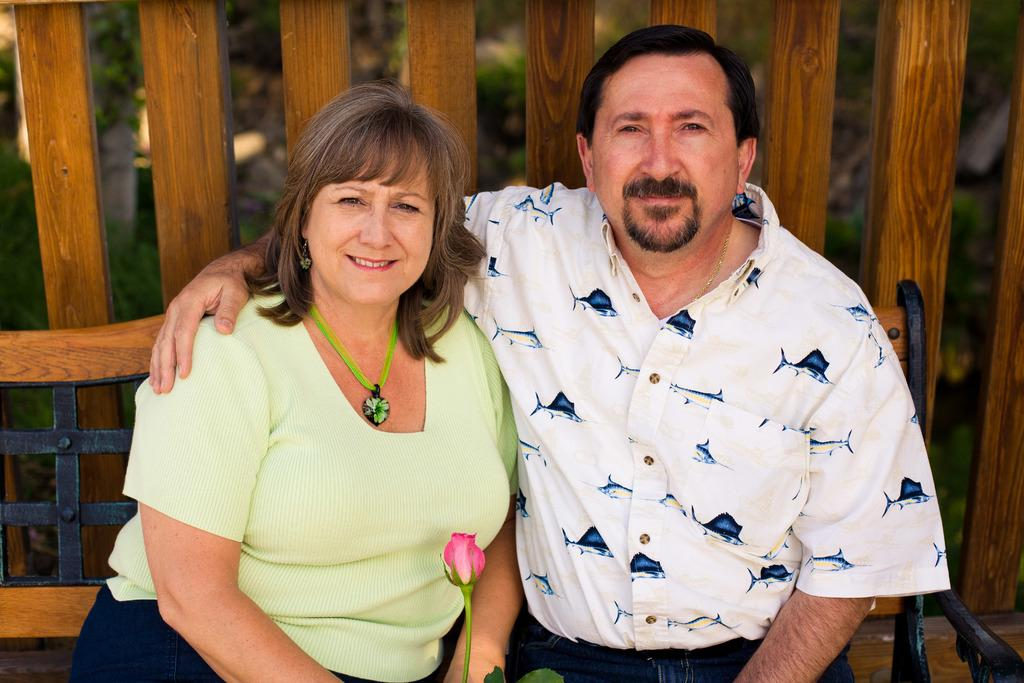How many people are sitting on the bench in the image? There are two persons sitting on a bench in the image. What is one of the persons holding? One person is holding a pink-colored rose. What can be seen in the background of the image? Wooden logs, grass, and plants are visible in the background. What type of oil is being used to lubricate the planes in the image? There are no planes present in the image, so there is no oil being used to lubricate them. 